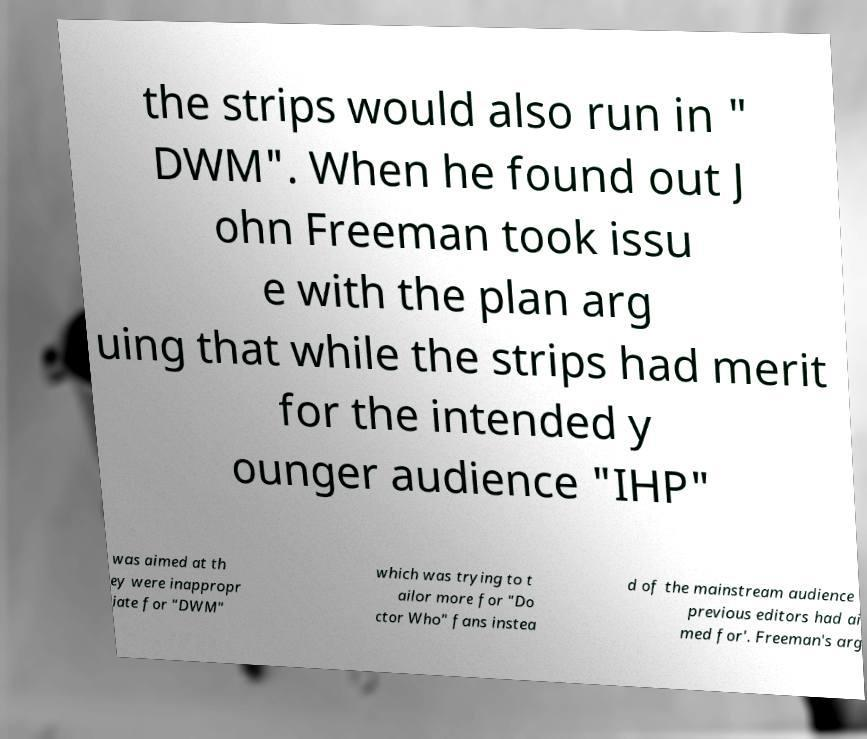Could you assist in decoding the text presented in this image and type it out clearly? the strips would also run in " DWM". When he found out J ohn Freeman took issu e with the plan arg uing that while the strips had merit for the intended y ounger audience "IHP" was aimed at th ey were inappropr iate for "DWM" which was trying to t ailor more for "Do ctor Who" fans instea d of the mainstream audience previous editors had ai med for'. Freeman's arg 